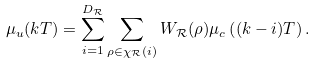<formula> <loc_0><loc_0><loc_500><loc_500>\mu _ { u } ( k T ) = \sum _ { i = 1 } ^ { D _ { \mathcal { R } } } \sum _ { \rho \in \chi _ { \mathcal { R } } ( i ) } W _ { \mathcal { R } } ( \rho ) \mu _ { c } \left ( ( k - i ) T \right ) .</formula> 